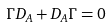Convert formula to latex. <formula><loc_0><loc_0><loc_500><loc_500>\Gamma D _ { A } + D _ { A } \Gamma = 0</formula> 